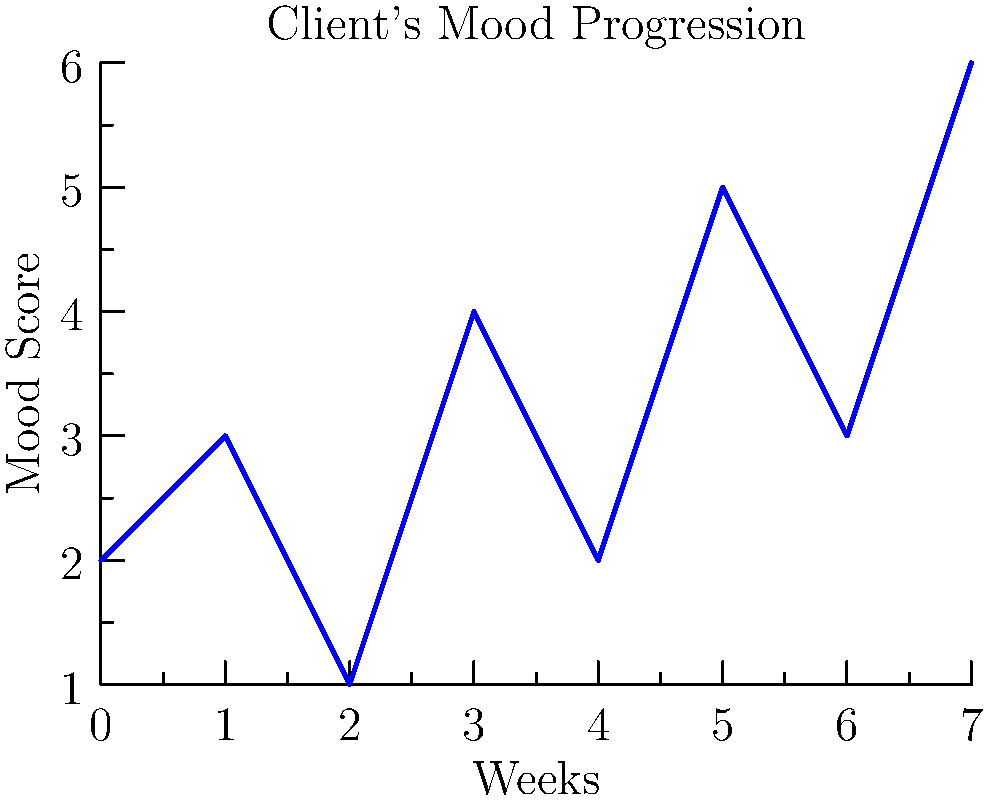Based on the line graph showing a client's mood progression over 8 weeks, what is the overall trend of the client's mood, and what week shows the most significant improvement from the previous week? To answer this question, we need to analyze the line graph step by step:

1. Overall trend:
   - Look at the start point (week 0) and end point (week 7) of the graph.
   - The mood score starts at 2 and ends at 6.
   - This indicates an overall upward trend in the client's mood.

2. Week-to-week changes:
   - Week 0 to 1: Increase from 2 to 3
   - Week 1 to 2: Decrease from 3 to 1
   - Week 2 to 3: Increase from 1 to 4
   - Week 3 to 4: Decrease from 4 to 2
   - Week 4 to 5: Increase from 2 to 5
   - Week 5 to 6: Decrease from 5 to 3
   - Week 6 to 7: Increase from 3 to 6

3. Most significant improvement:
   - The largest positive change is from week 4 to week 5, where the mood score increases by 3 points (from 2 to 5).

Therefore, the overall trend is improving, and the most significant improvement occurs in week 5.
Answer: Improving trend; Week 5 